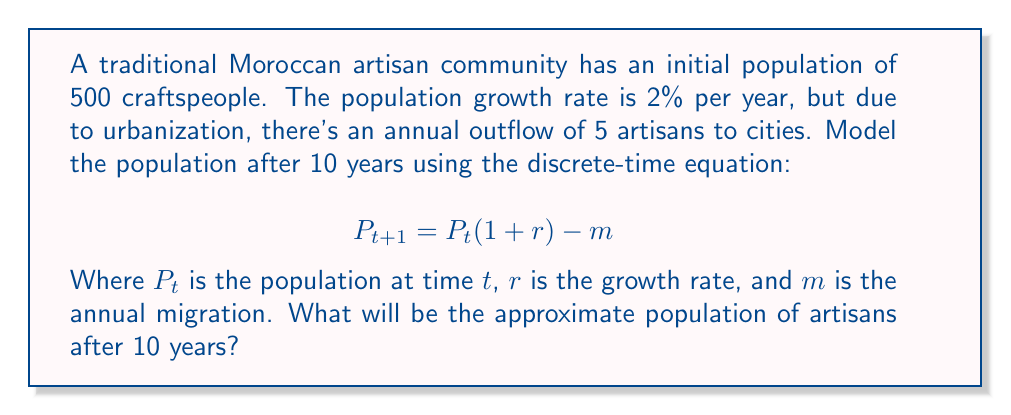What is the answer to this math problem? Let's solve this step-by-step:

1) We are given:
   Initial population $P_0 = 500$
   Growth rate $r = 0.02$ (2%)
   Annual migration $m = 5$
   Time $t = 10$ years

2) We'll use the equation $P_{t+1} = P_t(1 + r) - m$ iteratively for 10 years:

   Year 1: $P_1 = 500(1 + 0.02) - 5 = 510 - 5 = 505$
   Year 2: $P_2 = 505(1 + 0.02) - 5 = 515.10 - 5 = 510.10$
   Year 3: $P_3 = 510.10(1 + 0.02) - 5 = 520.30 - 5 = 515.30$

3) Continuing this process for 10 years, we get:

   Year 10: $P_{10} \approx 547.92$

4) Rounding to the nearest whole number, as we can't have a fractional number of artisans:

   $P_{10} \approx 548$ artisans
Answer: 548 artisans 